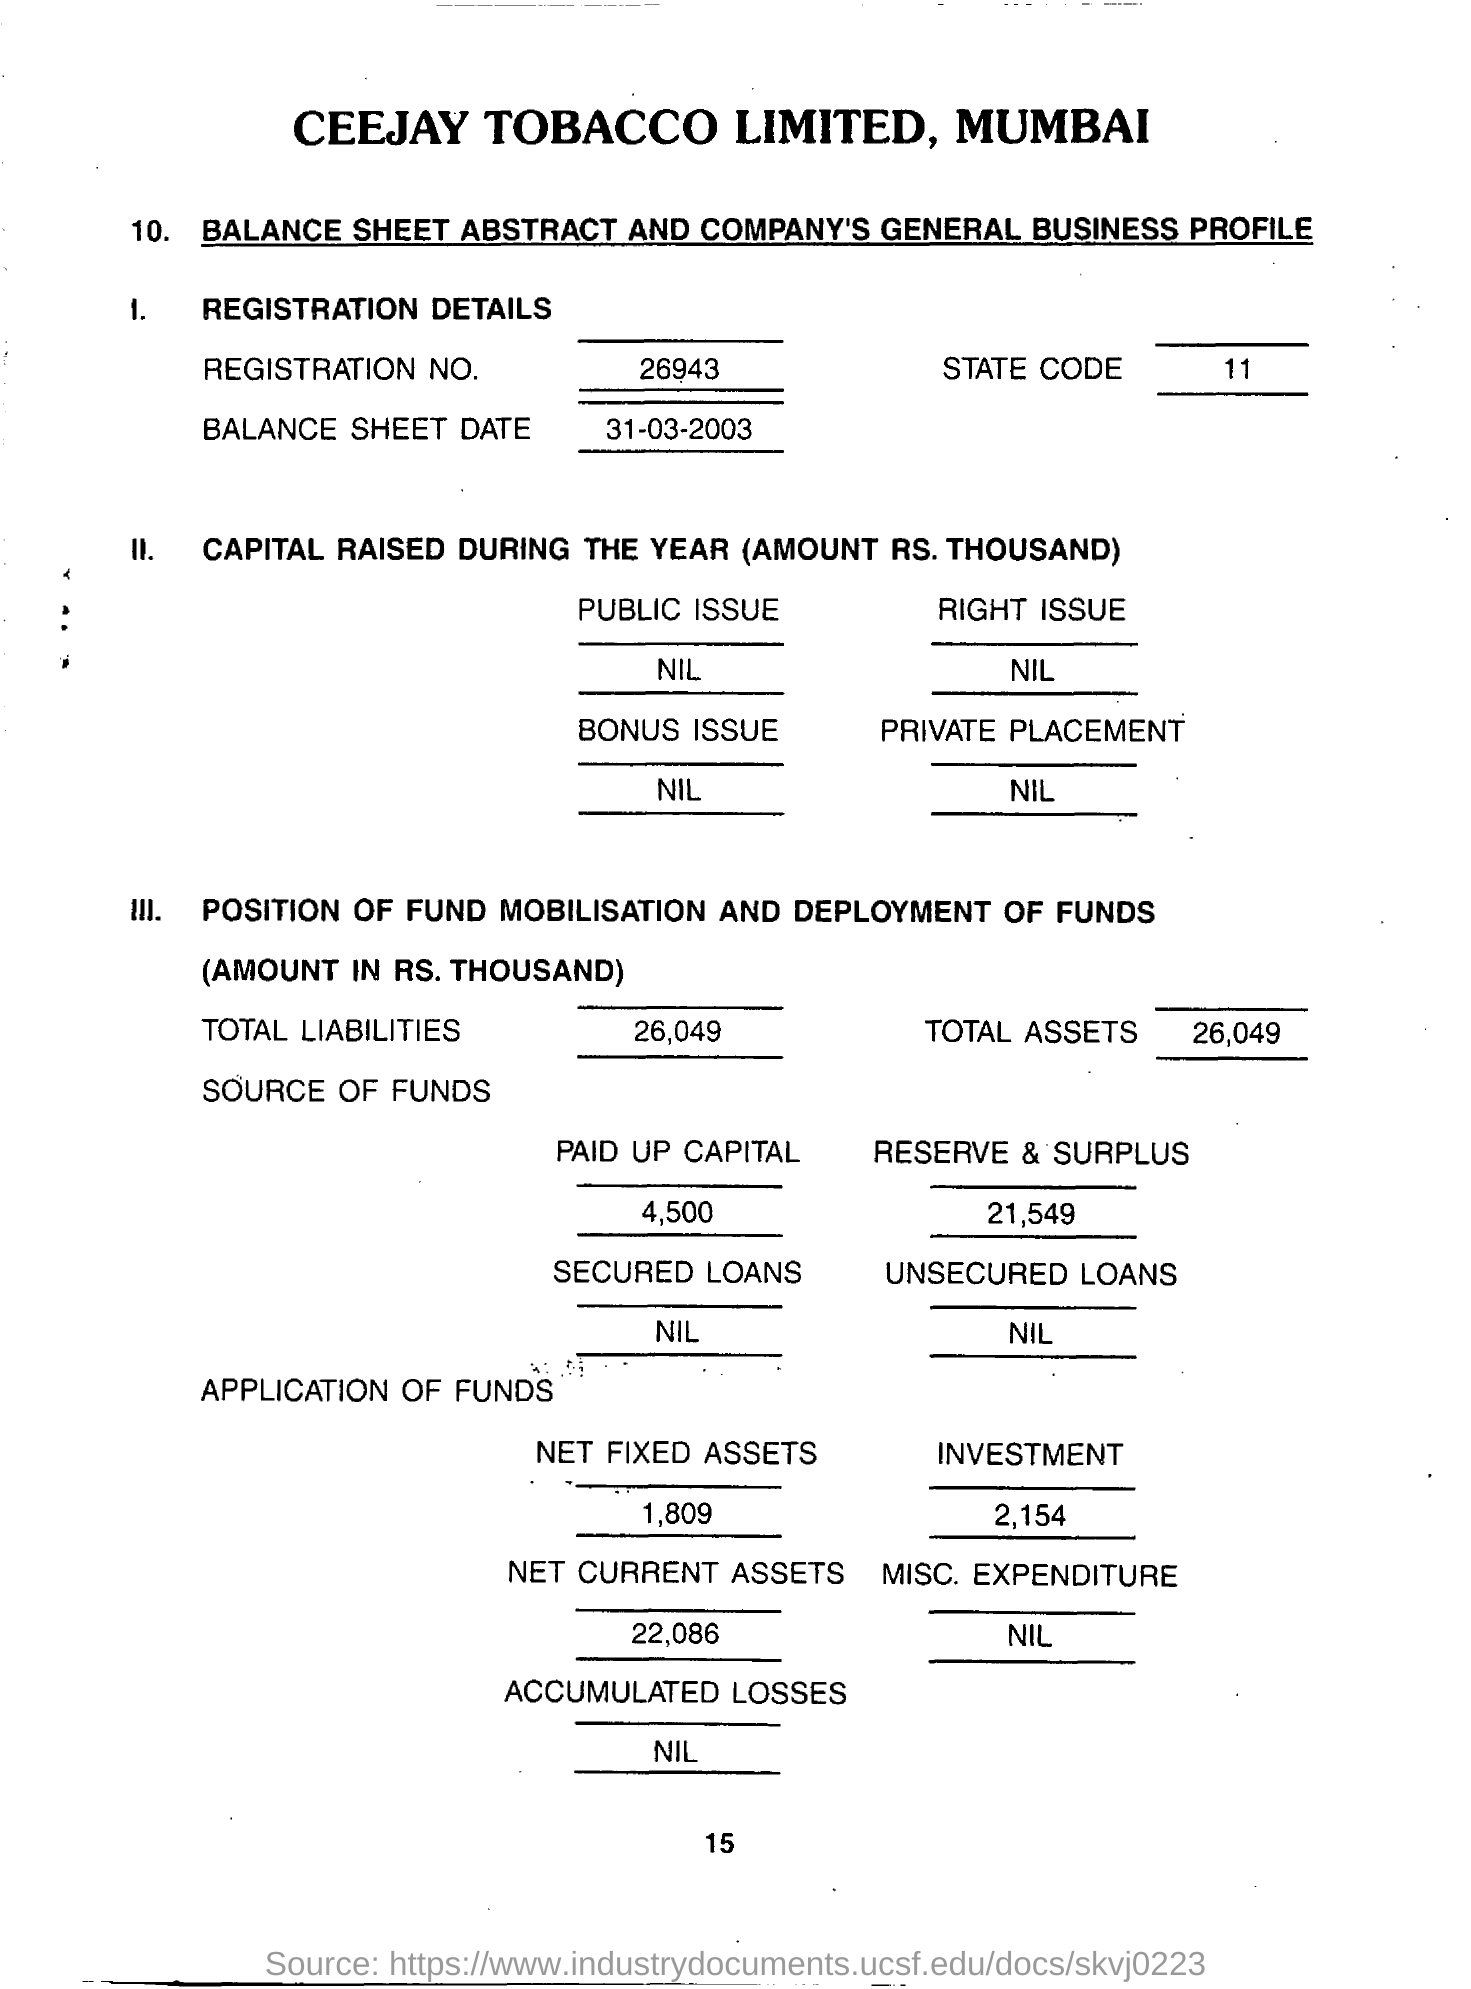Draw attention to some important aspects in this diagram. The paid-up capital is 4,500. The Public Issue Field is empty, which means there is no information available. The registration number is 26943. The total assets are 26,049. The balance sheet date is March 31, 2003. 